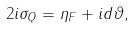<formula> <loc_0><loc_0><loc_500><loc_500>2 i \sigma _ { Q } = \eta _ { F } + i d \vartheta ,</formula> 